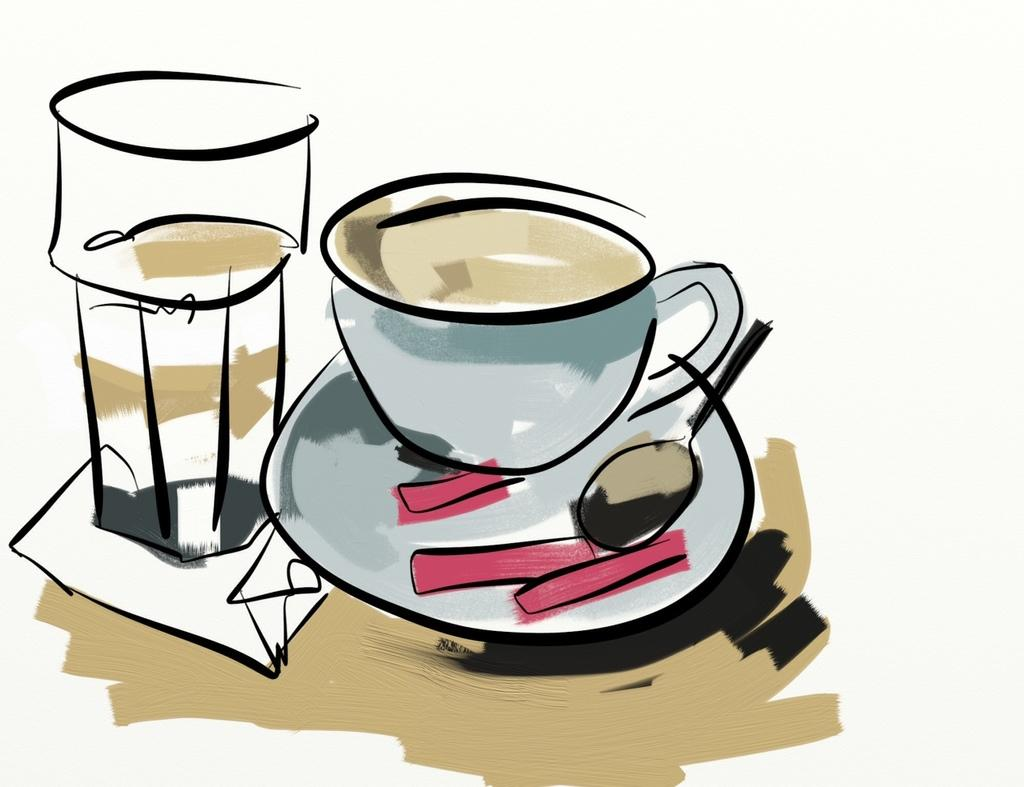What type of dishware is visible in the image? There is a glass and a cup in the image. What utensil is present in the image? There is a spoon in the image. Where is the spoon located in relation to the saucer? The spoon is in a saucer. Where are the glass, cup, and spoon placed? They are on a table. What is the nature of the image? The image appears to be a painting. How many ants can be seen crawling on the canvas in the image? There are no ants present in the image, and the image is a painting, not a canvas. 